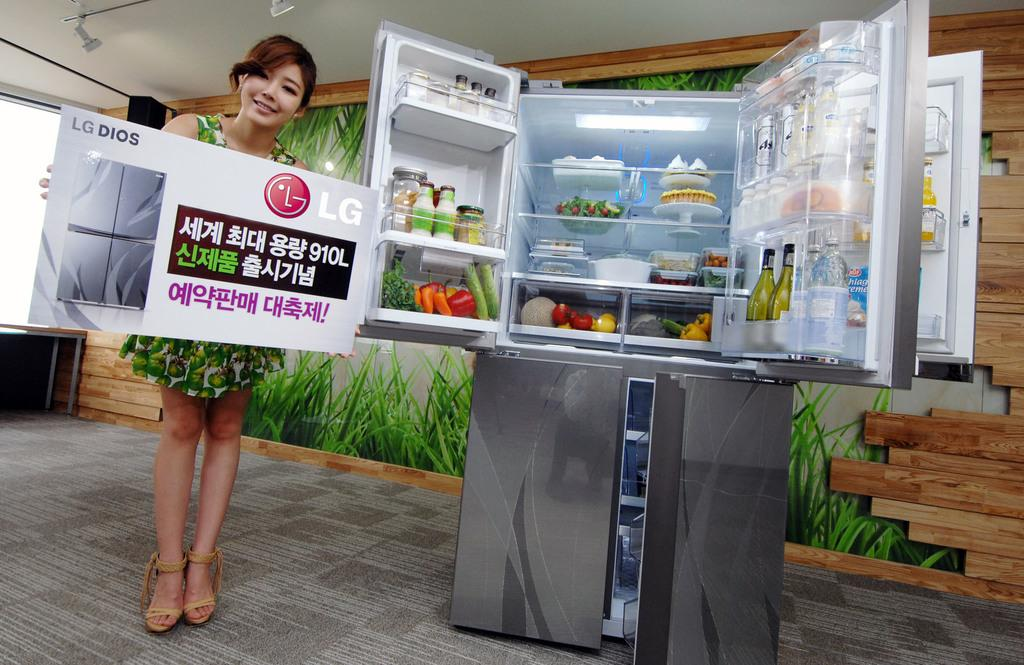<image>
Describe the image concisely. A woman holding a sign for LG Dios next to an open refrigerator 